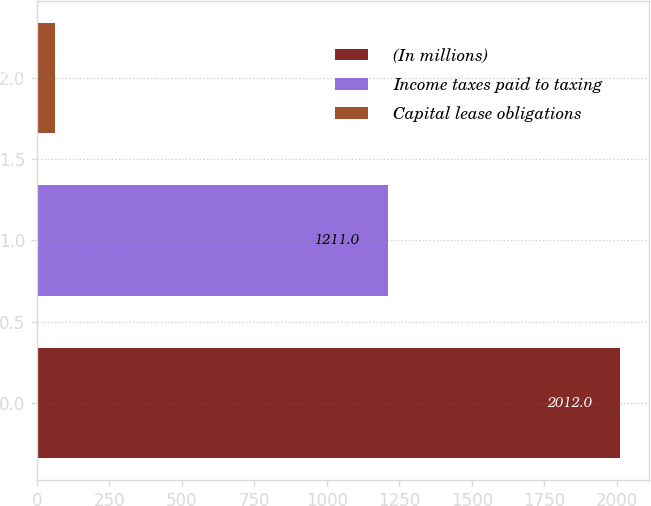Convert chart. <chart><loc_0><loc_0><loc_500><loc_500><bar_chart><fcel>(In millions)<fcel>Income taxes paid to taxing<fcel>Capital lease obligations<nl><fcel>2012<fcel>1211<fcel>62<nl></chart> 